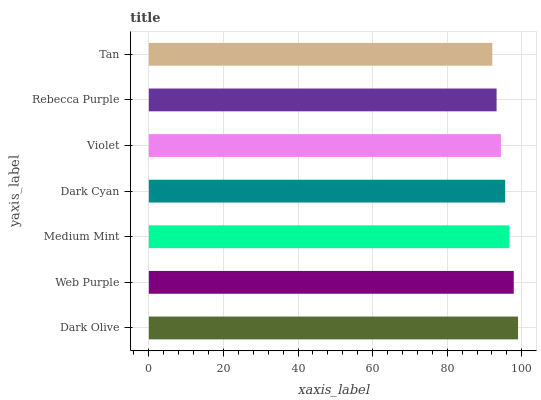Is Tan the minimum?
Answer yes or no. Yes. Is Dark Olive the maximum?
Answer yes or no. Yes. Is Web Purple the minimum?
Answer yes or no. No. Is Web Purple the maximum?
Answer yes or no. No. Is Dark Olive greater than Web Purple?
Answer yes or no. Yes. Is Web Purple less than Dark Olive?
Answer yes or no. Yes. Is Web Purple greater than Dark Olive?
Answer yes or no. No. Is Dark Olive less than Web Purple?
Answer yes or no. No. Is Dark Cyan the high median?
Answer yes or no. Yes. Is Dark Cyan the low median?
Answer yes or no. Yes. Is Violet the high median?
Answer yes or no. No. Is Violet the low median?
Answer yes or no. No. 